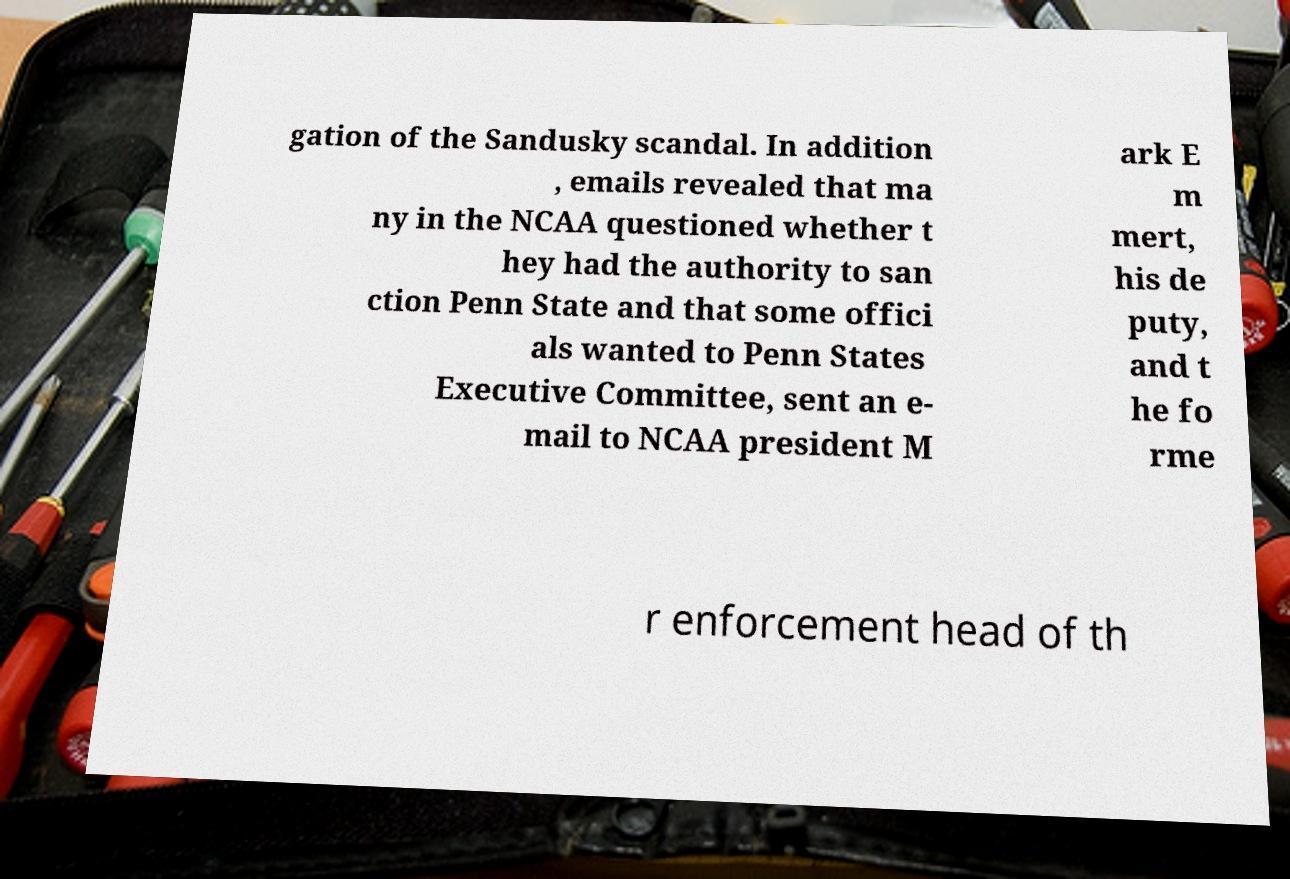Please identify and transcribe the text found in this image. gation of the Sandusky scandal. In addition , emails revealed that ma ny in the NCAA questioned whether t hey had the authority to san ction Penn State and that some offici als wanted to Penn States Executive Committee, sent an e- mail to NCAA president M ark E m mert, his de puty, and t he fo rme r enforcement head of th 